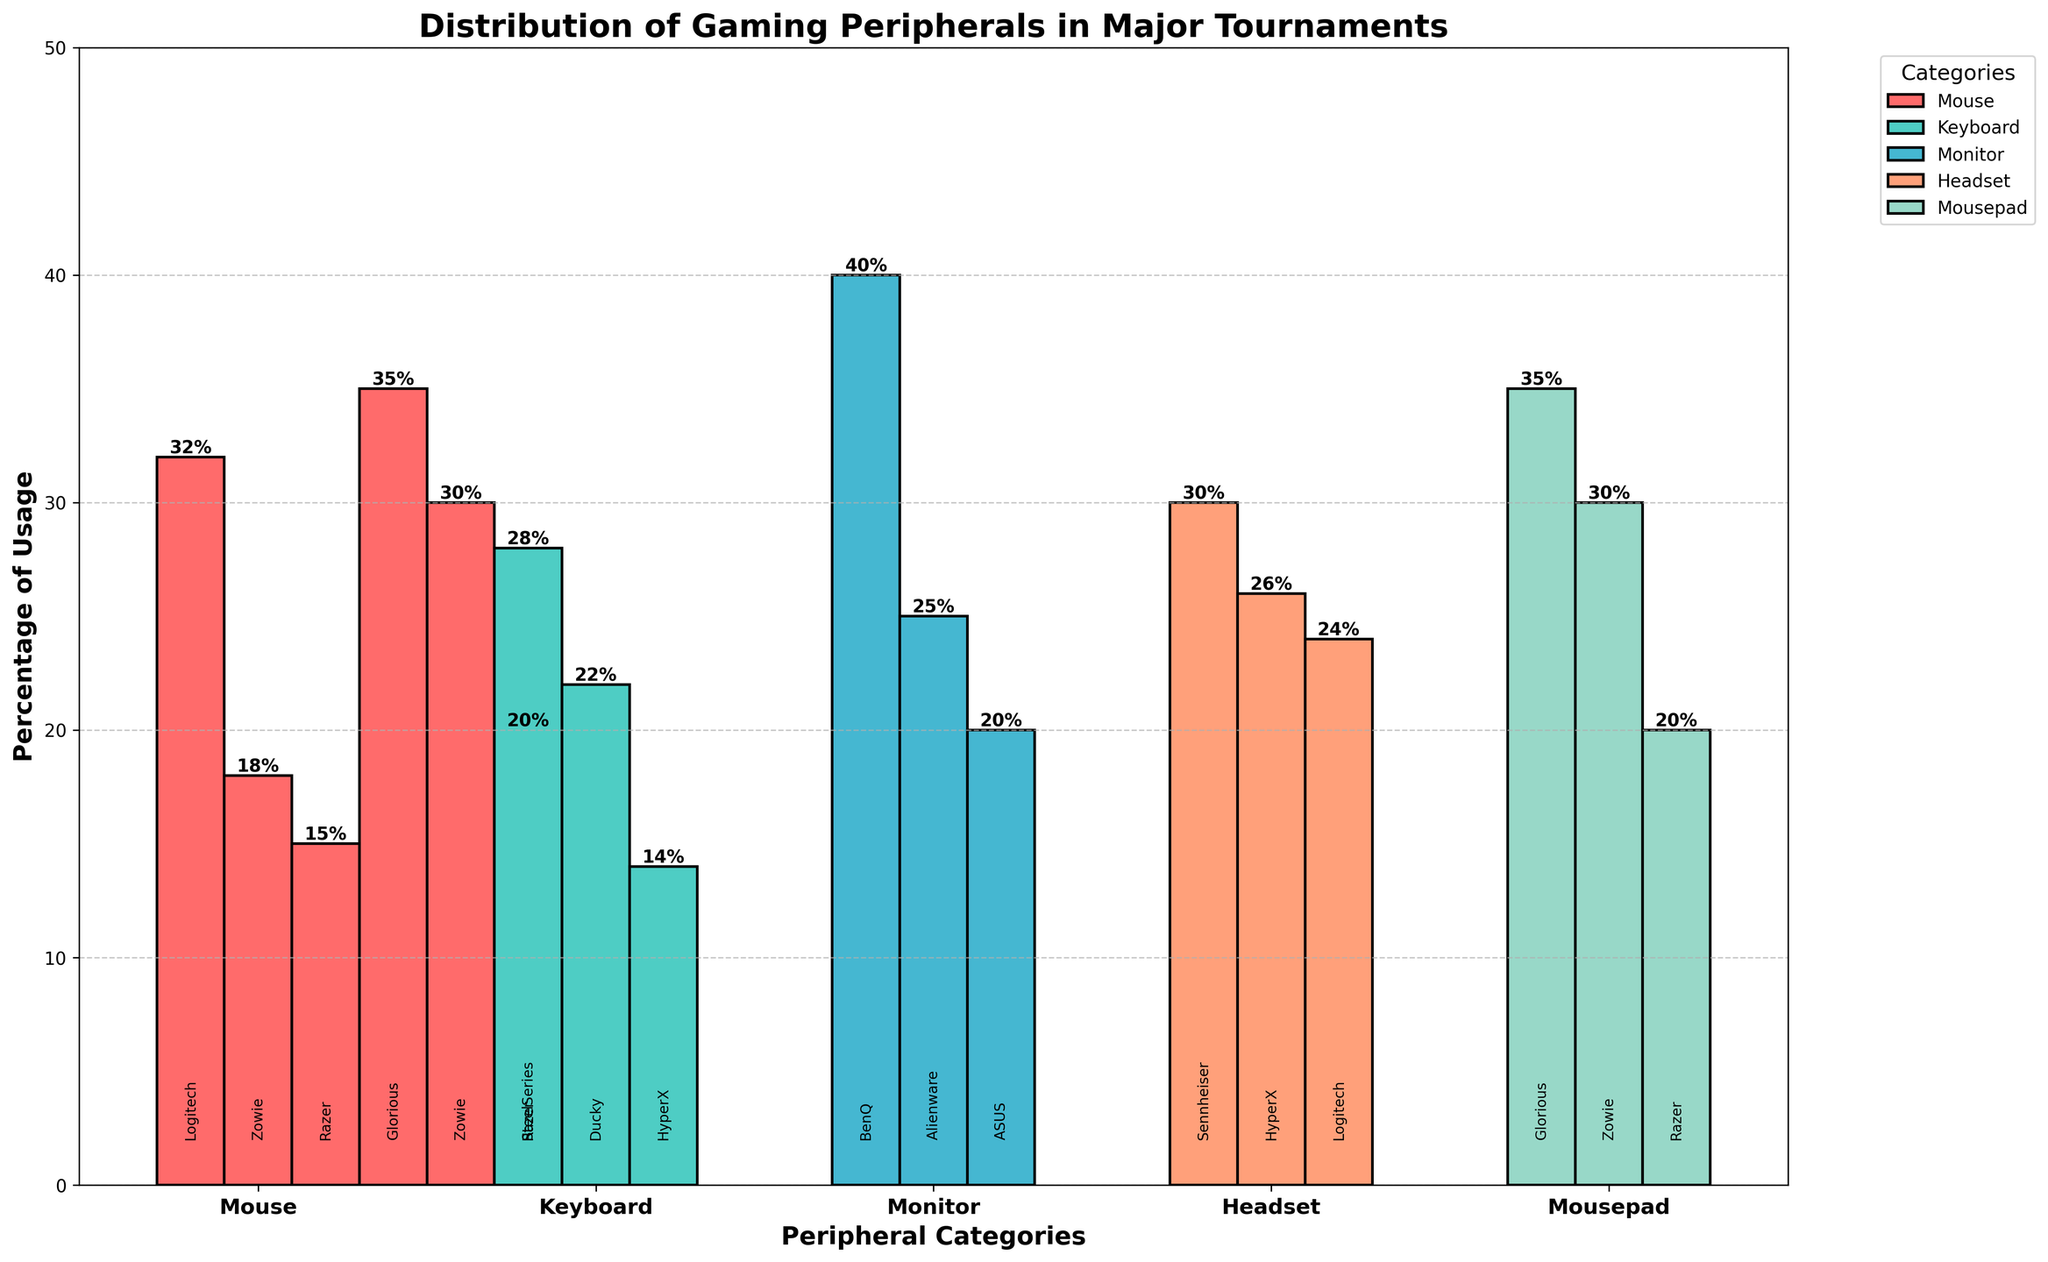What percentage of professional players use a Logitech headset? Look at the bar that represents the Logitech G Pro X Headset and read the percentage value on top of it.
Answer: 24% Which category of peripherals has the highest usage percentage, and what is that percentage? Identify the bar with the highest value across all categories. The highest bar represents the BenQ XL2546K Monitor with a percentage of 40%.
Answer: Monitor, 40% What is the difference in usage percentage between the most popular mouse and the least popular keyboard? The most popular mouse is the Logitech G Pro X Superlight Mouse with 32%, and the least popular keyboard is the HyperX Alloy FPS Pro Keyboard with 14%. The difference is 32% - 14%.
Answer: 18% How does the usage percentage of Razer Viper Ultimate Mouse compare to ASUS ROG Swift 360Hz Monitor? Look at the values of the bars representing the Razer Viper Ultimate Mouse and the ASUS ROG Swift 360Hz Monitor. Razer Viper Ultimate Mouse is 15%, and ASUS ROG Swift 360Hz Monitor is 20%.
Answer: The monitor usage is 5% higher than the mouse Which mousepad brand has the second highest usage percentage, and what is that percentage? Examine the bar heights for mousepads. Glorious 3XL Mousepad has the highest (35%), and Zowie G-SR-SE Mousepad has the second highest (30%).
Answer: Zowie G-SR-SE, 30% What is the total percentage of players using either the Logitech G Pro X Superlight Mouse or the Zowie EC2 Mouse? Sum the percentages of the Logitech G Pro X Superlight Mouse (32%) and Zowie EC2 Mouse (18%).
Answer: 50% Compare the total usage percentage of the most popular headset and mousepad. Which one has a higher usage, and by how much? The most popular headset (Sennheiser GSP 600) is 30%, and the most popular mousepad (Glorious 3XL) is 35%. Compare the two values.
Answer: Mousepad is higher by 5% Among the keyboards, which brand is used by the fewest players? Identify the brand with the smallest percentage among the keyboards. HyperX Alloy FPS Pro Keyboard is the least used at 14%.
Answer: HyperX Consider the total percentage of usage for all headsets combined. What is this total? Sum up the usage percentages of Sennheiser GSP 600 (30%), HyperX Cloud II (26%), and Logitech G Pro X Headset (24%). 30% + 26% + 24% = 80%.
Answer: 80% What is the average percentage usage of all the mouse brands shown? Sum up the percentages of all mouse brands and then divide by the number of mouse brands. (32% + 18% + 15%) / 3 = 65% / 3 = approximately 21.67%.
Answer: approximately 21.67% 